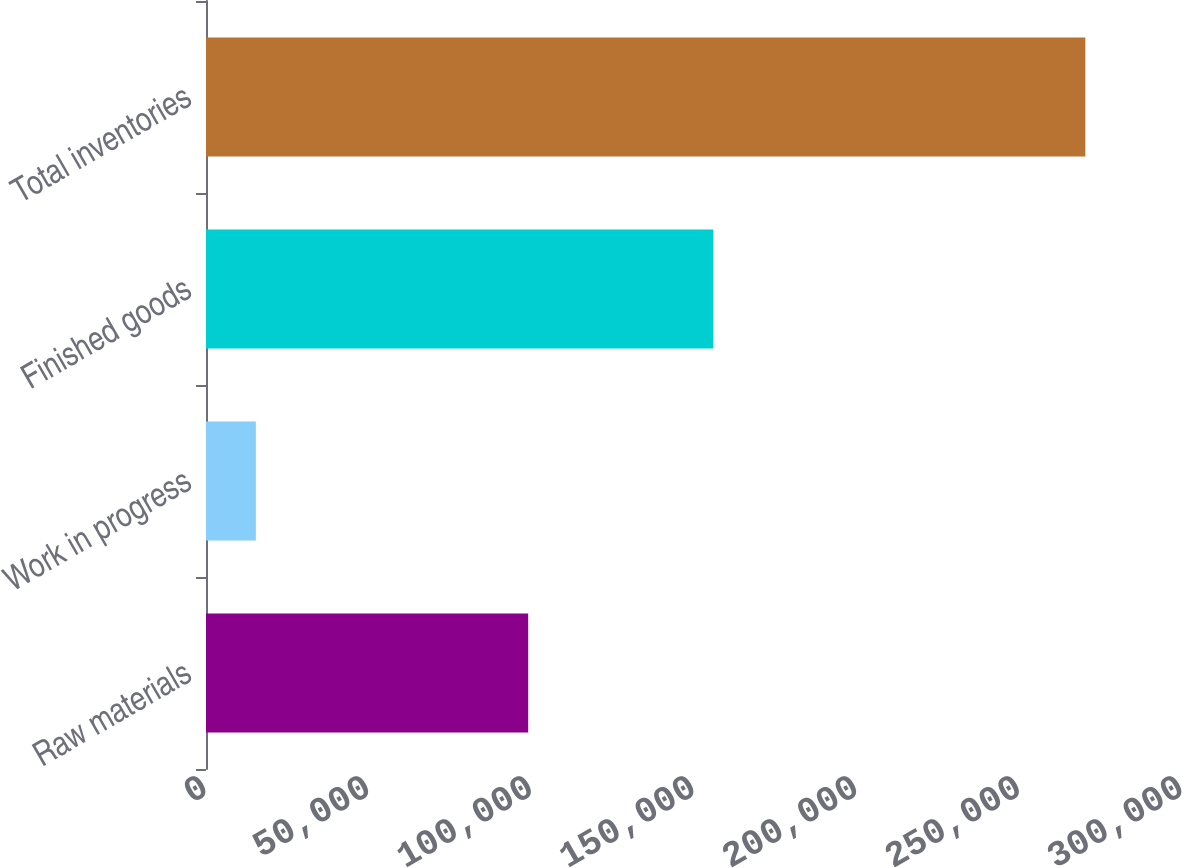<chart> <loc_0><loc_0><loc_500><loc_500><bar_chart><fcel>Raw materials<fcel>Work in progress<fcel>Finished goods<fcel>Total inventories<nl><fcel>99033<fcel>15324<fcel>155937<fcel>270294<nl></chart> 